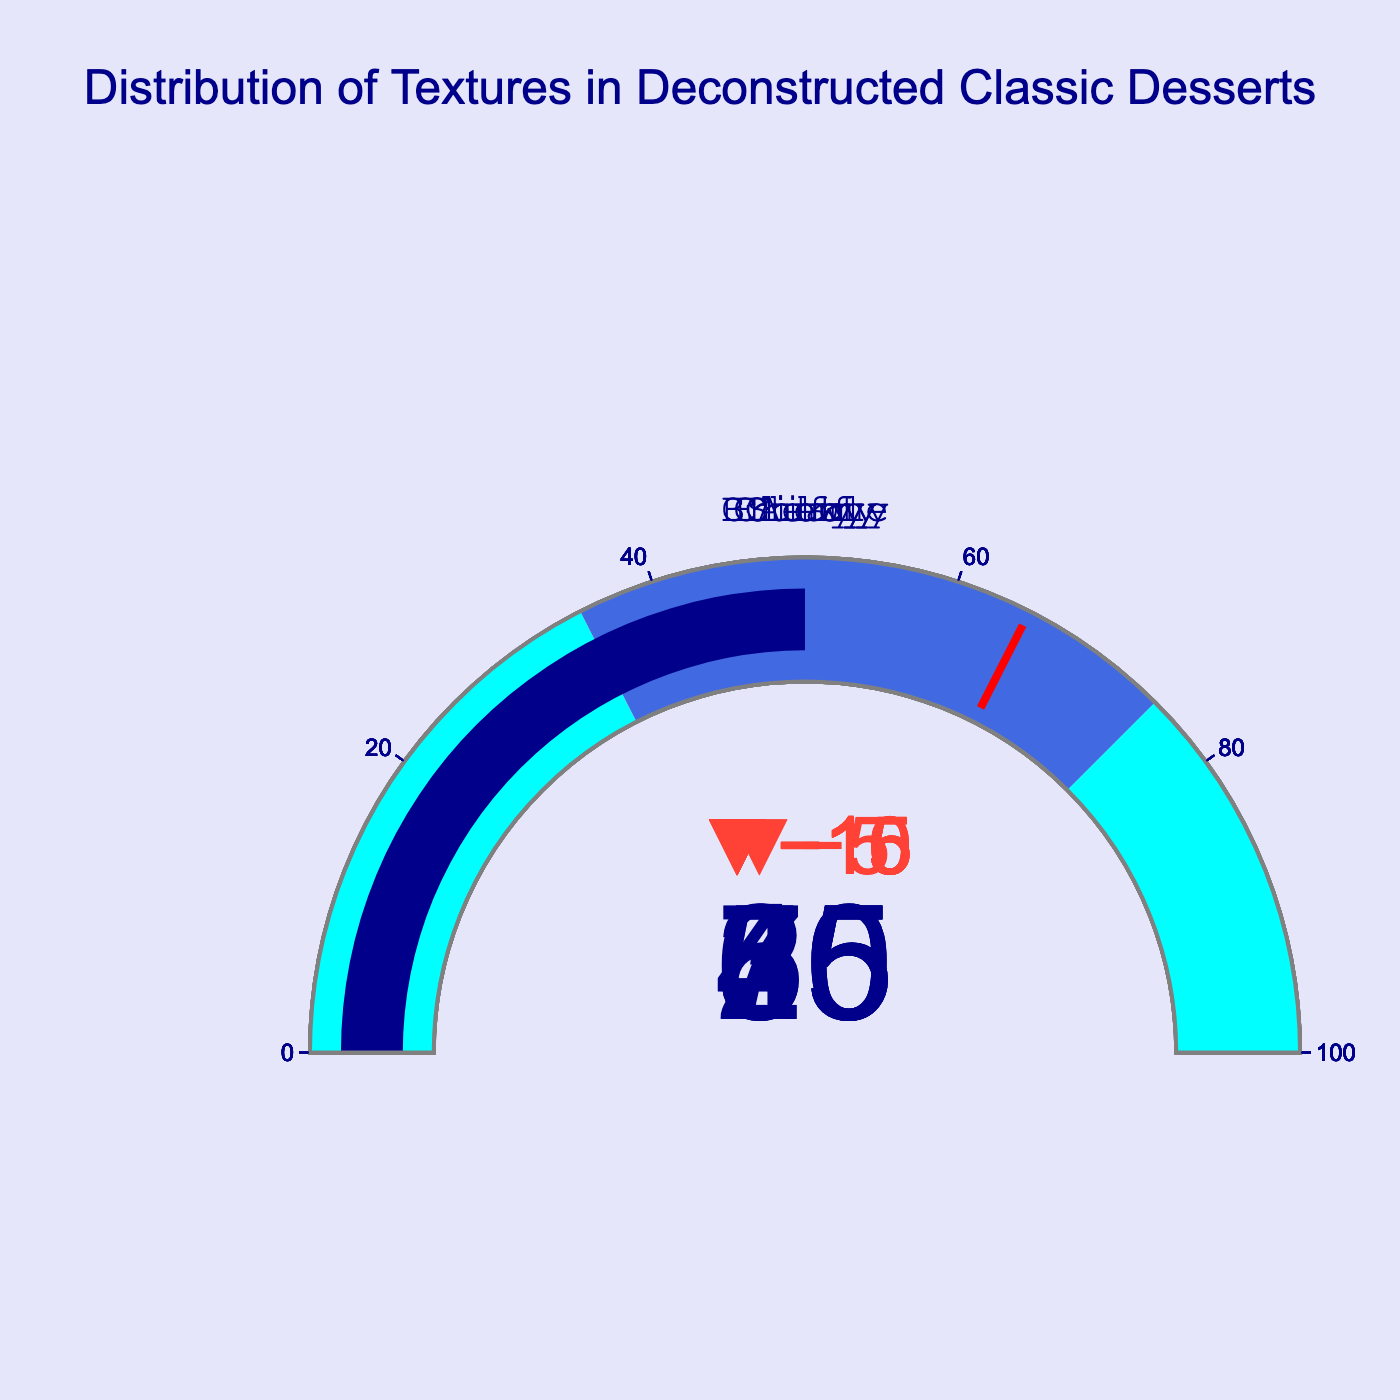What is the title of the plot? The title of the plot is usually displayed at the top of the figure in a large and bold font. In this case, it reads "Distribution of Textures in Deconstructed Classic Desserts".
Answer: Distribution of Textures in Deconstructed Classic Desserts How many textures are displayed in the bullet chart? By counting the number of gauges, each representing a texture, you can determine that there are seven textures displayed.
Answer: Seven What is the actual value for the "Creamy" texture? Locate the gauge titled "Creamy" and look at the number displayed prominently. This number represents the actual value for that texture.
Answer: 70 Which texture has the largest difference between actual value and target value? By examining each gauge, compare the actual value and the target value for each texture. Compute the difference and identify the largest one.
Answer: Crunchy Are any of the textures' actual values lower than the start of their range? Compare each texture's actual value with the start of its range. None of the actual values fall below their respective range starts.
Answer: No What's the difference between the actual value of "Airy" and its target value? Subtract the target value from the actual value for the "Airy" texture gauge. The difference calculation is 45 (actual) - 60 (target).
Answer: -15 Which textures have an actual value that falls between their range start and range end? For each texture gauge, compare its actual value to its range start and range end. The textures "Crunchy", "Creamy", and "Fluffy" have their actual values within their ranges.
Answer: Crunchy, Creamy, Fluffy Which texture has the lowest actual value? By examining the actual values displayed across all textures, identify the lowest one.
Answer: Brittle Of the textures with actual values above 50, which one has the target value closest to its actual value? Identify textures with actual values above 50, and then compare their target values to decide which target is closest to the actual value.
Answer: Creamy By how much does the "Chewy" texture's actual value fall short of its target value? Subtract the actual value from the target value for the "Chewy" texture. The difference is 40 (target) - 30 (actual).
Answer: 10 